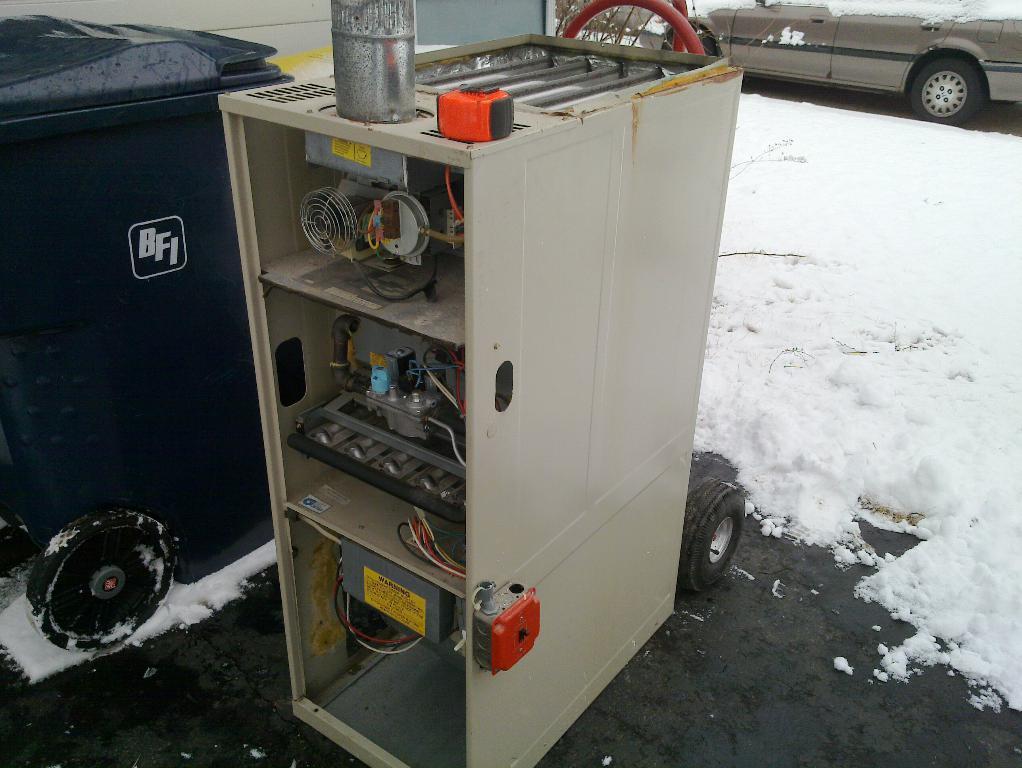Please provide a concise description of this image. In this image we can see one wall, some objects on the surface, one car on the road with some snow, so much of snow on the surface, one box and one machine on the surface. 